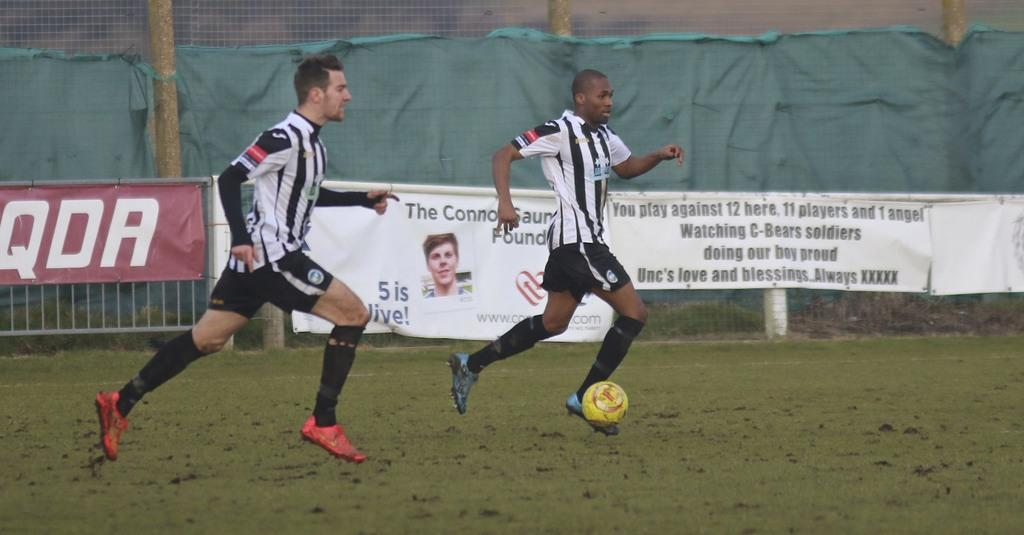What type of barrier can be seen in the image? There is a fence in the image. What is the large sheet of paper used for in the image? There is a cover sheet in the image, which is typically used for covering or protecting surfaces. What type of advertisement or announcement is visible in the image? There is a hoarding in the image, which is a large board used for advertising or displaying information. What activity are two men engaged in within the image? Two men are playing football in a playground in the image. How many cattle are present in the image? There are no cattle present in the image. What type of jump is being performed by the men playing football in the image? The image does not show any jumping activity; it only shows the men playing football. 